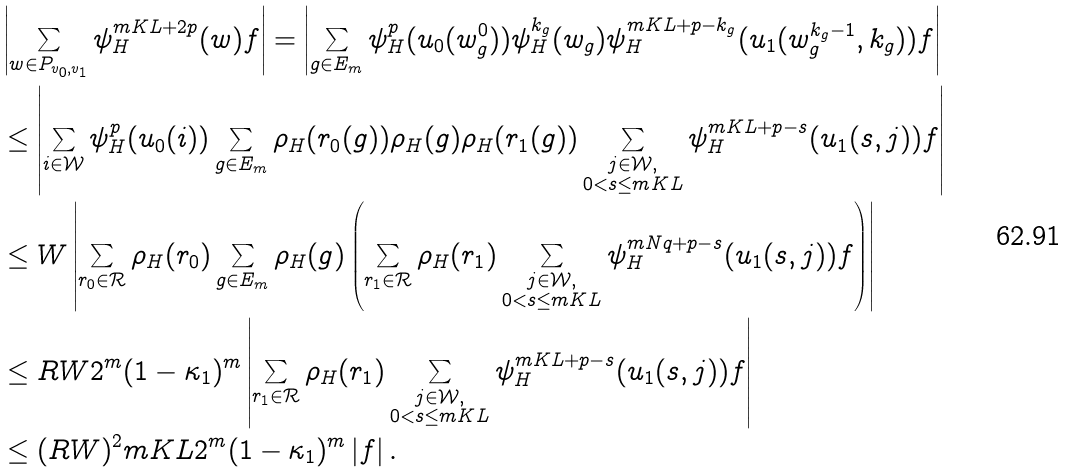<formula> <loc_0><loc_0><loc_500><loc_500>& \left | \sum _ { w \in P _ { v _ { 0 } , v _ { 1 } } } \psi _ { H } ^ { m K L + 2 p } ( w ) f \right | = \left | \sum _ { g \in E _ { m } } \psi _ { H } ^ { p } ( u _ { 0 } ( w ^ { 0 } _ { g } ) ) \psi _ { H } ^ { k _ { g } } ( w _ { g } ) \psi _ { H } ^ { m K L + p - k _ { g } } ( u _ { 1 } ( w _ { g } ^ { k _ { g } - 1 } , k _ { g } ) ) f \right | \\ & \leq \left | \sum _ { i \in \mathcal { W } } \psi _ { H } ^ { p } ( u _ { 0 } ( i ) ) \sum _ { g \in E _ { m } } \rho _ { H } ( r _ { 0 } ( g ) ) \rho _ { H } ( g ) \rho _ { H } ( r _ { 1 } ( g ) ) \sum _ { \substack { j \in \mathcal { W } , \\ 0 < s \leq m K L } } \psi _ { H } ^ { m K L + p - s } ( u _ { 1 } ( s , j ) ) f \right | \\ & \leq W \left | \sum _ { r _ { 0 } \in \mathcal { R } } \rho _ { H } ( r _ { 0 } ) \sum _ { g \in E _ { m } } \rho _ { H } ( g ) \left ( \sum _ { r _ { 1 } \in \mathcal { R } } \rho _ { H } ( r _ { 1 } ) \sum _ { \substack { j \in \mathcal { W } , \\ 0 < s \leq m K L } } \psi _ { H } ^ { m N q + p - s } ( u _ { 1 } ( s , j ) ) f \right ) \right | \\ & \leq R W 2 ^ { m } ( 1 - \kappa _ { 1 } ) ^ { m } \left | \sum _ { r _ { 1 } \in \mathcal { R } } \rho _ { H } ( r _ { 1 } ) \sum _ { \substack { j \in \mathcal { W } , \\ 0 < s \leq m K L } } \psi _ { H } ^ { m K L + p - s } ( u _ { 1 } ( s , j ) ) f \right | \\ & \leq ( R W ) ^ { 2 } m K L 2 ^ { m } ( 1 - \kappa _ { 1 } ) ^ { m } \left | f \right | .</formula> 